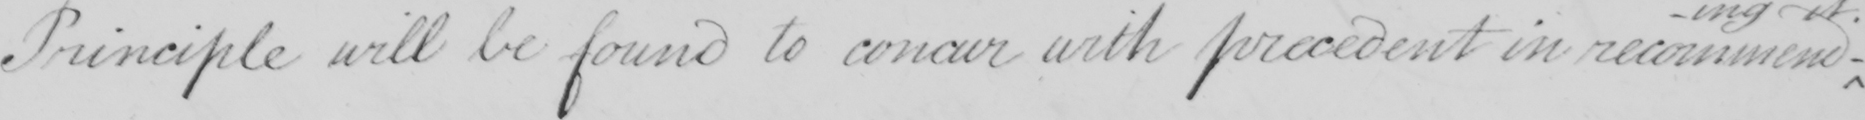Transcribe the text shown in this historical manuscript line. Principle will be found to concur with precedent in recommend 